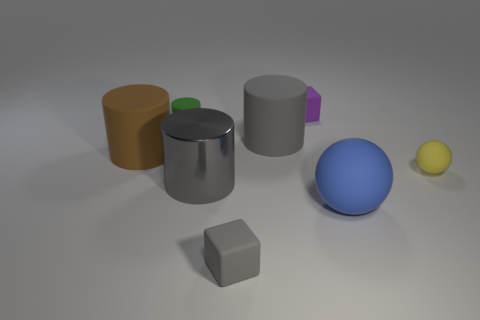Could you infer the lighting situation in the scene? The lighting in the scene comes from the upper left, casting soft shadows to the lower right of the objects. This is based on the shadow position and the bright reflective spot seen on the shiny surfaces, like on the larger gray cylinder and the blue sphere. 